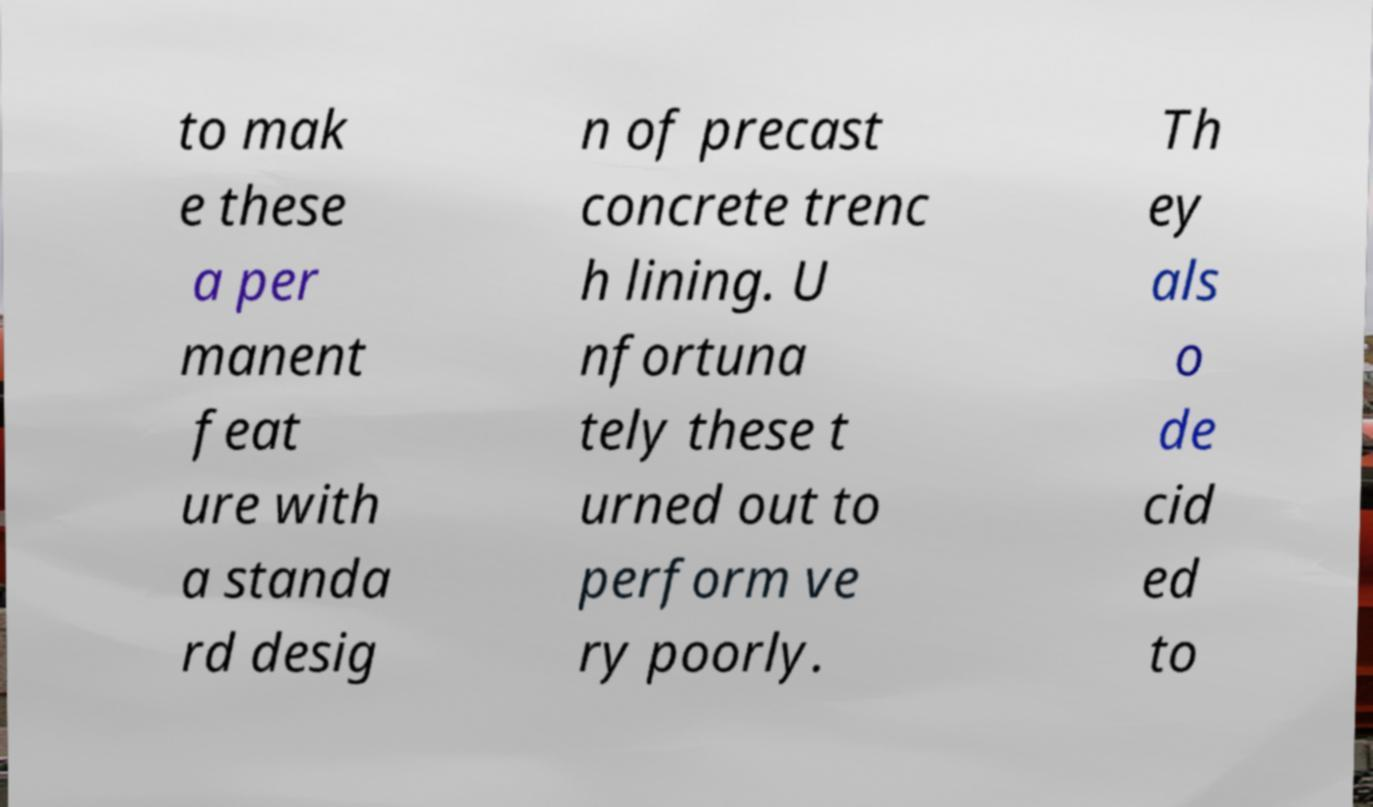For documentation purposes, I need the text within this image transcribed. Could you provide that? to mak e these a per manent feat ure with a standa rd desig n of precast concrete trenc h lining. U nfortuna tely these t urned out to perform ve ry poorly. Th ey als o de cid ed to 